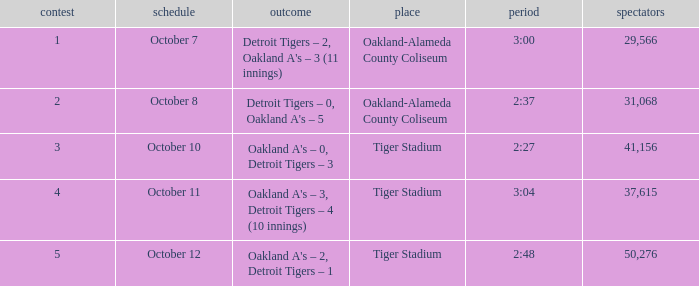What was the score at Tiger Stadium on October 12? Oakland A's – 2, Detroit Tigers – 1. 